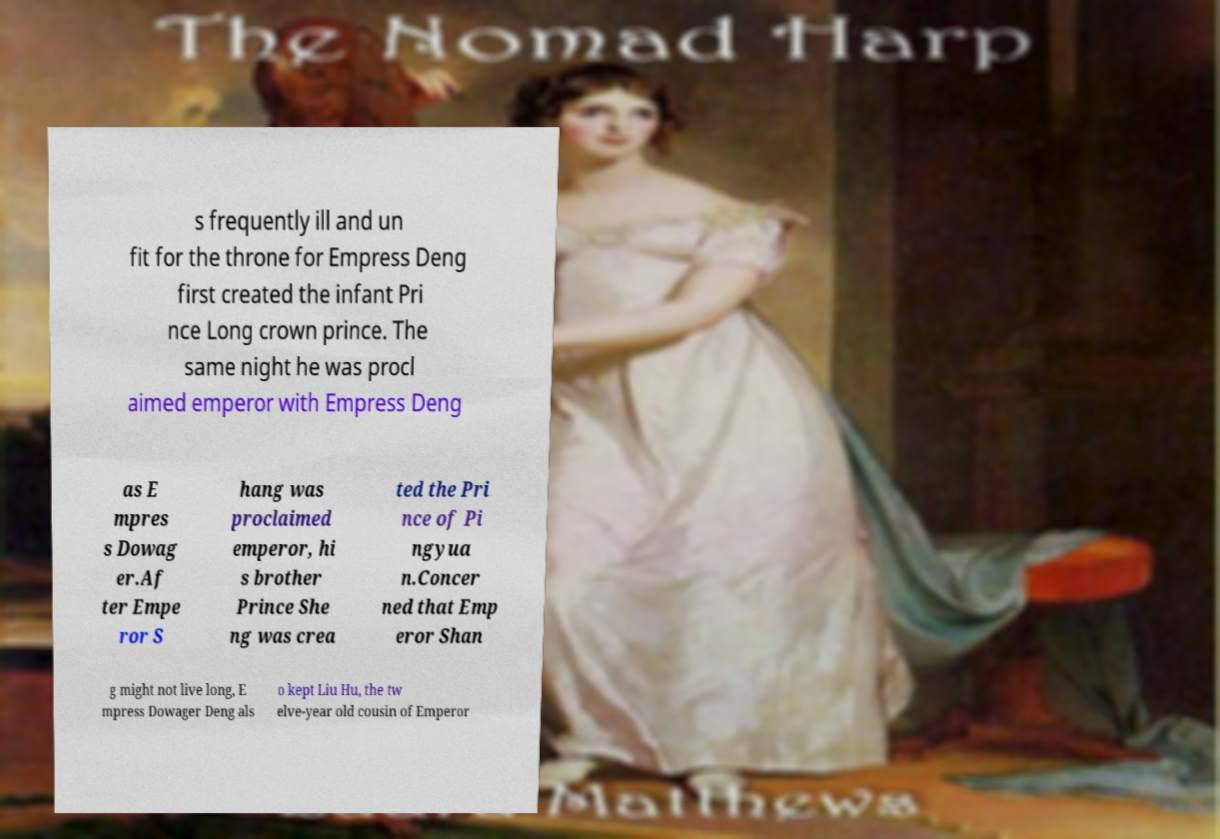Please identify and transcribe the text found in this image. s frequently ill and un fit for the throne for Empress Deng first created the infant Pri nce Long crown prince. The same night he was procl aimed emperor with Empress Deng as E mpres s Dowag er.Af ter Empe ror S hang was proclaimed emperor, hi s brother Prince She ng was crea ted the Pri nce of Pi ngyua n.Concer ned that Emp eror Shan g might not live long, E mpress Dowager Deng als o kept Liu Hu, the tw elve-year old cousin of Emperor 